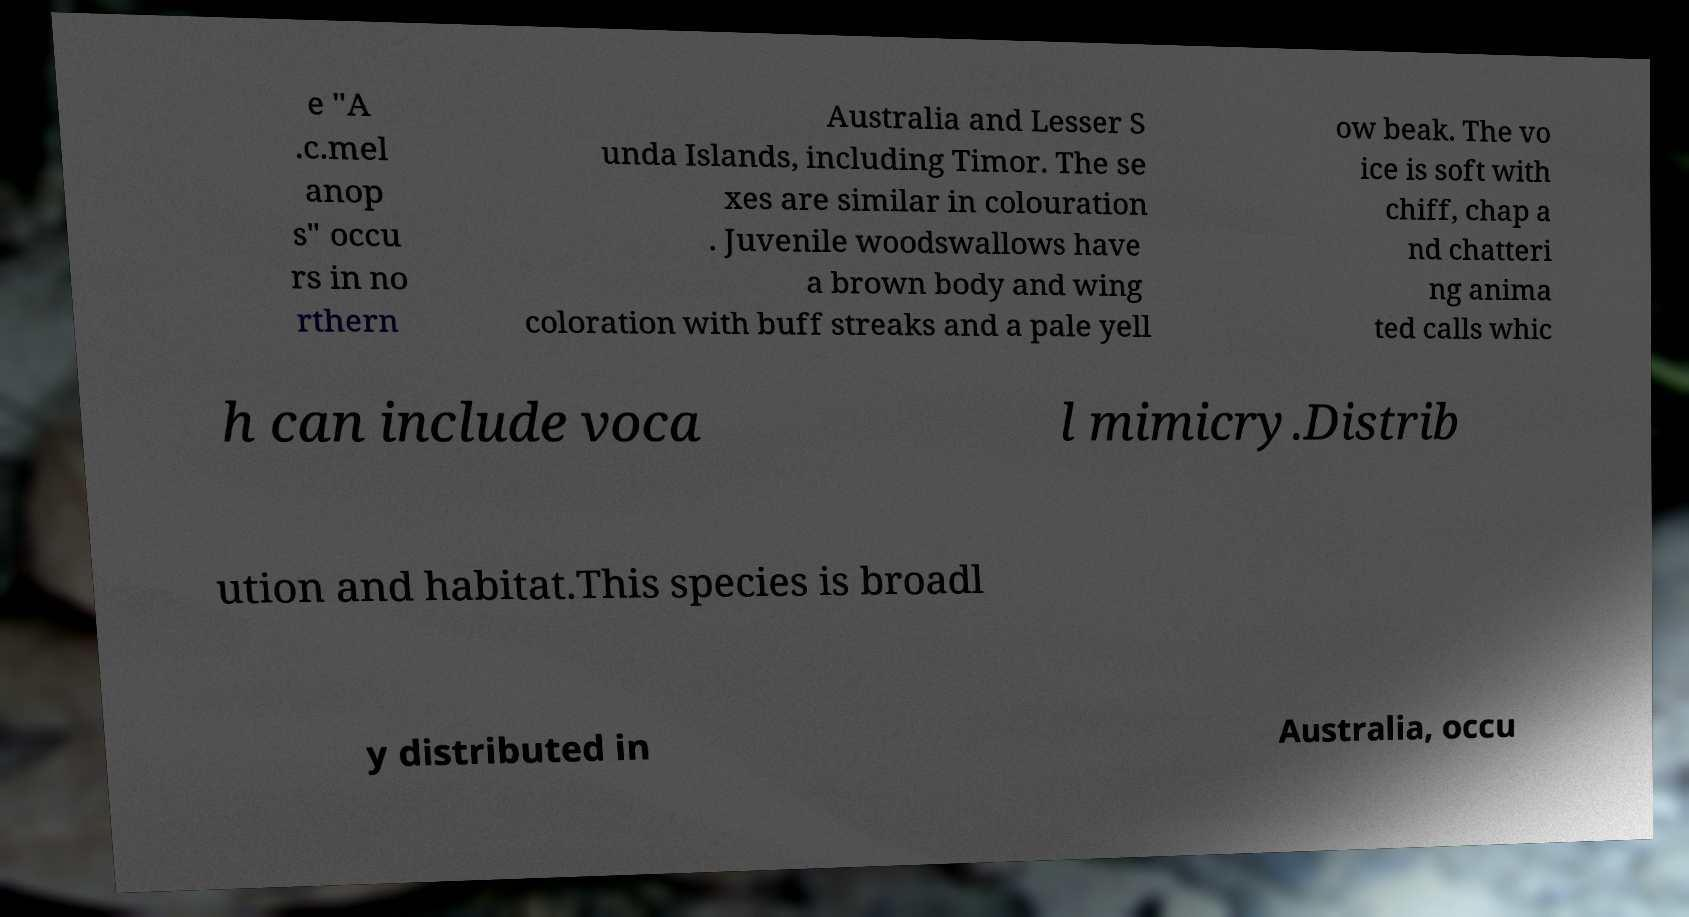Can you read and provide the text displayed in the image?This photo seems to have some interesting text. Can you extract and type it out for me? e "A .c.mel anop s" occu rs in no rthern Australia and Lesser S unda Islands, including Timor. The se xes are similar in colouration . Juvenile woodswallows have a brown body and wing coloration with buff streaks and a pale yell ow beak. The vo ice is soft with chiff, chap a nd chatteri ng anima ted calls whic h can include voca l mimicry.Distrib ution and habitat.This species is broadl y distributed in Australia, occu 